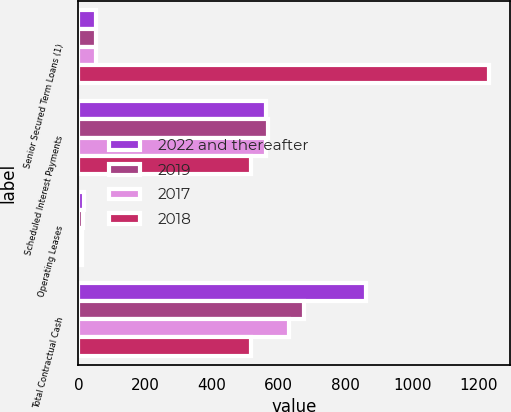<chart> <loc_0><loc_0><loc_500><loc_500><stacked_bar_chart><ecel><fcel>Senior Secured Term Loans (1)<fcel>Scheduled Interest Payments<fcel>Operating Leases<fcel>Total Contractual Cash<nl><fcel>2022 and thereafter<fcel>53.1<fcel>562.3<fcel>16.8<fcel>861.5<nl><fcel>2019<fcel>53.1<fcel>567.7<fcel>14<fcel>676.4<nl><fcel>2017<fcel>53.1<fcel>563.2<fcel>11.6<fcel>631.1<nl><fcel>2018<fcel>1230.3<fcel>516.4<fcel>9.9<fcel>516.4<nl></chart> 